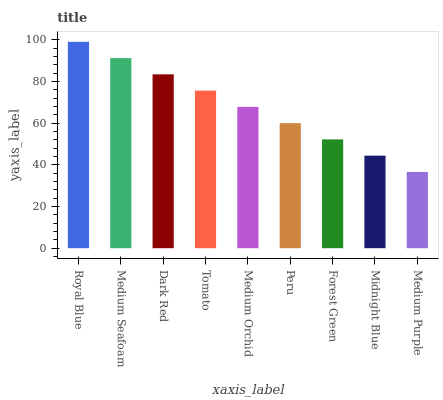Is Medium Seafoam the minimum?
Answer yes or no. No. Is Medium Seafoam the maximum?
Answer yes or no. No. Is Royal Blue greater than Medium Seafoam?
Answer yes or no. Yes. Is Medium Seafoam less than Royal Blue?
Answer yes or no. Yes. Is Medium Seafoam greater than Royal Blue?
Answer yes or no. No. Is Royal Blue less than Medium Seafoam?
Answer yes or no. No. Is Medium Orchid the high median?
Answer yes or no. Yes. Is Medium Orchid the low median?
Answer yes or no. Yes. Is Forest Green the high median?
Answer yes or no. No. Is Medium Purple the low median?
Answer yes or no. No. 